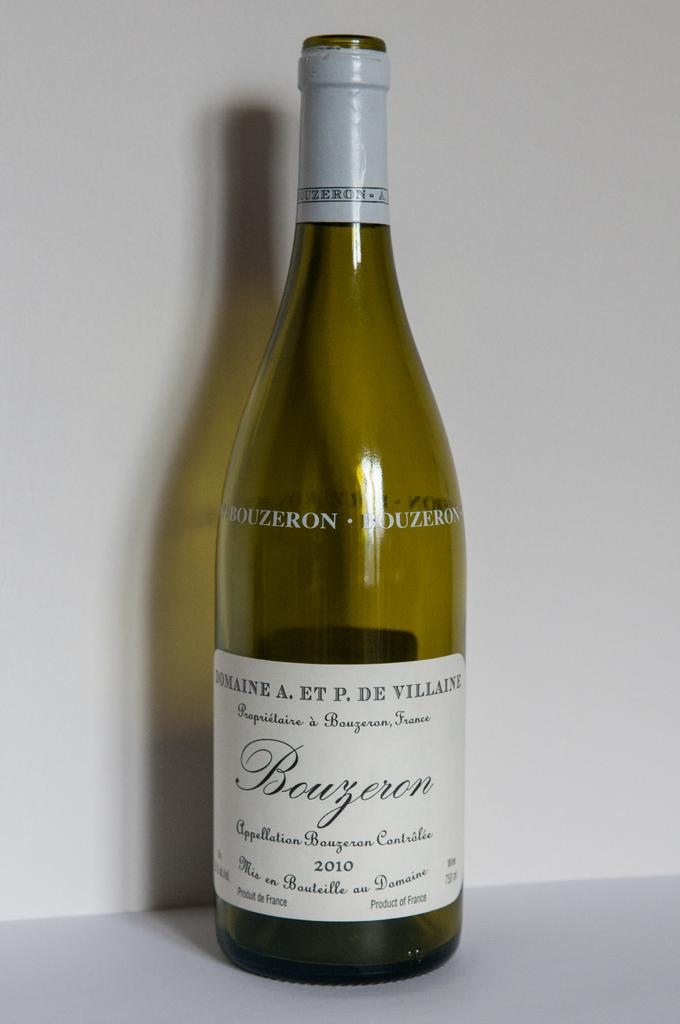What is the main object in the image? There is a wine bottle with a label in the image. What is the wine bottle placed on? The wine bottle is on an object. What can be seen in the background of the image? There is a wall in the background of the image. How many letters are written by the writer in the image? There is no writer or letters present in the image; it only features a wine bottle with a label and a wall in the background. 